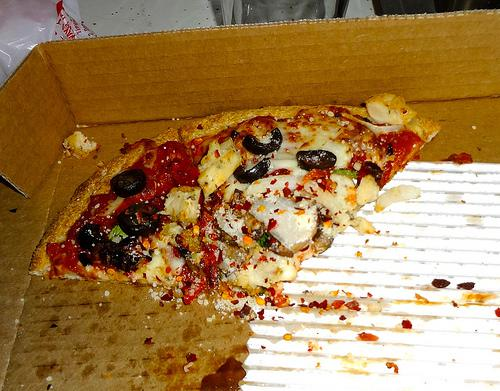Question: what is there?
Choices:
A. Popcorn.
B. Pizza slices.
C. Christmas trees.
D. Gifts.
Answer with the letter. Answer: B Question: what is one ingredient?
Choices:
A. Flour.
B. Eggs.
C. Chicken.
D. Olives.
Answer with the letter. Answer: D Question: who will eat the pizza?
Choices:
A. Someone.
B. Teenagers.
C. Children.
D. The baseball team.
Answer with the letter. Answer: A Question: what is on the sauce?
Choices:
A. Pepper.
B. Cheese.
C. Bread.
D. Onion.
Answer with the letter. Answer: B Question: why is it left there?
Choices:
A. It was moldy.
B. People were full.
C. No one liked it.
D. Everyone was on a diet.
Answer with the letter. Answer: B Question: where is the box sitting?
Choices:
A. Table.
B. Under the chair.
C. On a shelf.
D. By the door.
Answer with the letter. Answer: A 